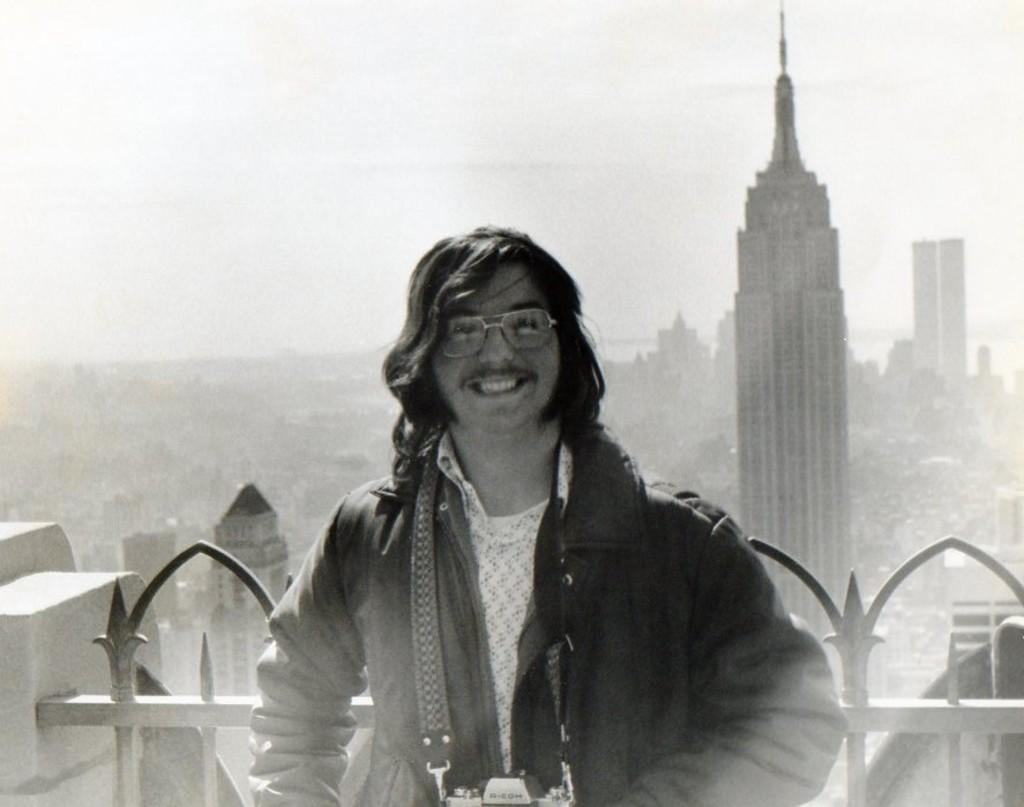Who is present in the image? There is a man in the image. What is the man's facial expression? The man is smiling. What can be seen in the background of the image? There are buildings in the background of the image. What specific structure is visible in the image? There is a tower in the image. What is visible at the top of the image? The sky is visible at the top of the image. How many bananas are being traded between the bears in the image? There are no bananas or bears present in the image. 